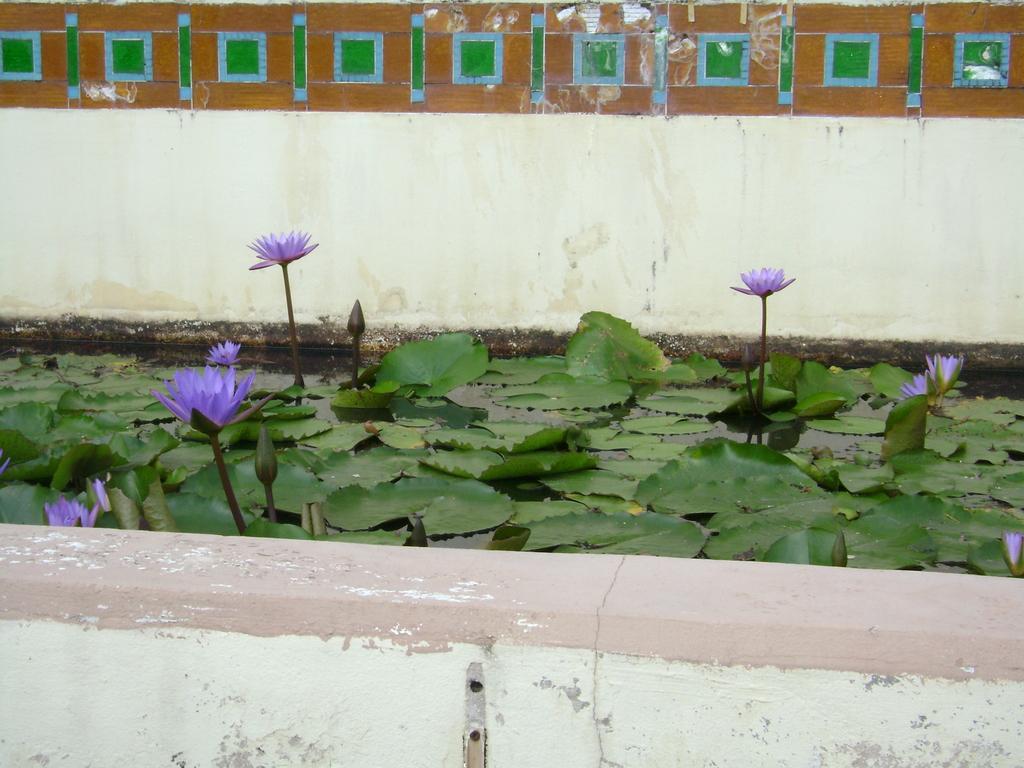Please provide a concise description of this image. In this image I can see the flowers in the water. I can see these flowers are in purple color. In the background I can see the wall. 